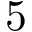Convert formula to latex. <formula><loc_0><loc_0><loc_500><loc_500>5</formula> 